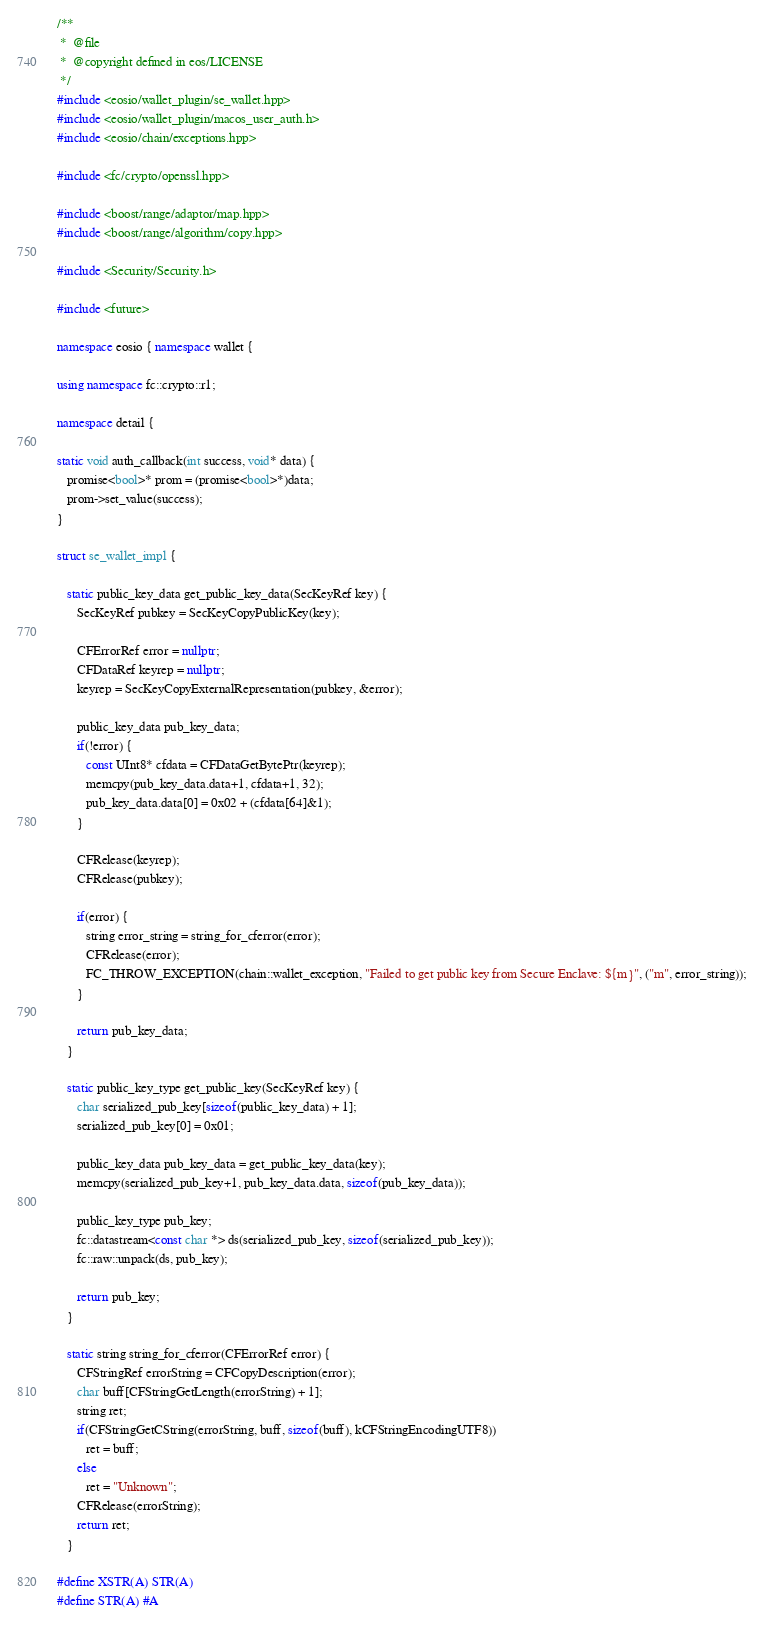<code> <loc_0><loc_0><loc_500><loc_500><_C++_>/**
 *  @file
 *  @copyright defined in eos/LICENSE
 */
#include <eosio/wallet_plugin/se_wallet.hpp>
#include <eosio/wallet_plugin/macos_user_auth.h>
#include <eosio/chain/exceptions.hpp>

#include <fc/crypto/openssl.hpp>

#include <boost/range/adaptor/map.hpp>
#include <boost/range/algorithm/copy.hpp>

#include <Security/Security.h>

#include <future>

namespace eosio { namespace wallet {

using namespace fc::crypto::r1;

namespace detail {

static void auth_callback(int success, void* data) {
   promise<bool>* prom = (promise<bool>*)data;
   prom->set_value(success);
}

struct se_wallet_impl {

   static public_key_data get_public_key_data(SecKeyRef key) {
      SecKeyRef pubkey = SecKeyCopyPublicKey(key);

      CFErrorRef error = nullptr;
      CFDataRef keyrep = nullptr;
      keyrep = SecKeyCopyExternalRepresentation(pubkey, &error);

      public_key_data pub_key_data;
      if(!error) {
         const UInt8* cfdata = CFDataGetBytePtr(keyrep);
         memcpy(pub_key_data.data+1, cfdata+1, 32);
         pub_key_data.data[0] = 0x02 + (cfdata[64]&1);
      }

      CFRelease(keyrep);
      CFRelease(pubkey);

      if(error) {
         string error_string = string_for_cferror(error);
         CFRelease(error);
         FC_THROW_EXCEPTION(chain::wallet_exception, "Failed to get public key from Secure Enclave: ${m}", ("m", error_string));
      }

      return pub_key_data;
   }

   static public_key_type get_public_key(SecKeyRef key) {
      char serialized_pub_key[sizeof(public_key_data) + 1];
      serialized_pub_key[0] = 0x01;

      public_key_data pub_key_data = get_public_key_data(key);
      memcpy(serialized_pub_key+1, pub_key_data.data, sizeof(pub_key_data));

      public_key_type pub_key;
      fc::datastream<const char *> ds(serialized_pub_key, sizeof(serialized_pub_key));
      fc::raw::unpack(ds, pub_key);

      return pub_key;
   }

   static string string_for_cferror(CFErrorRef error) {
      CFStringRef errorString = CFCopyDescription(error);
      char buff[CFStringGetLength(errorString) + 1];
      string ret;
      if(CFStringGetCString(errorString, buff, sizeof(buff), kCFStringEncodingUTF8))
         ret = buff;
      else
         ret = "Unknown";
      CFRelease(errorString);
      return ret;
   }

#define XSTR(A) STR(A)
#define STR(A) #A
</code> 